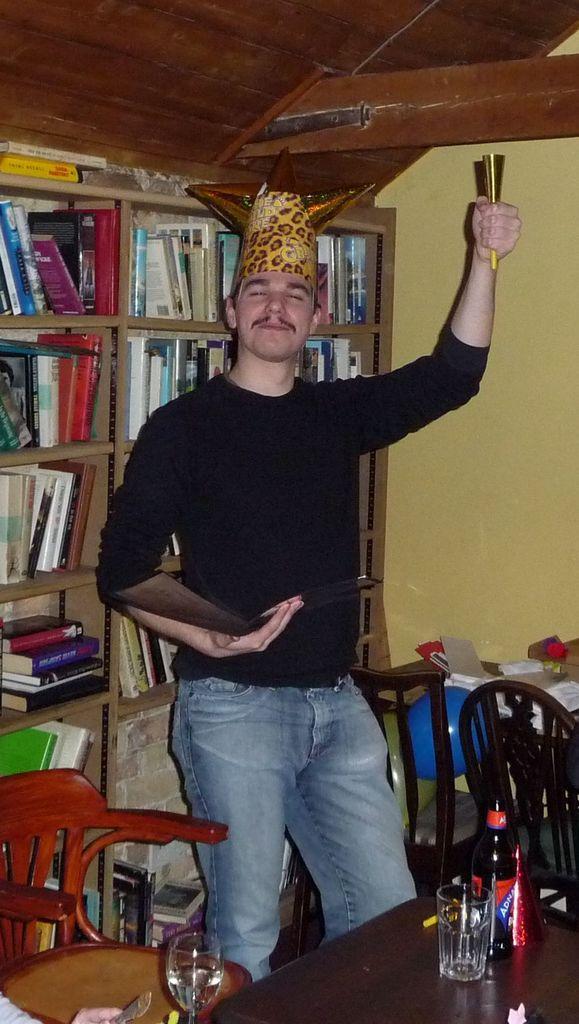Describe this image in one or two sentences. In this image there is a person wearing black color T-shirt standing and holding something in his left hand and in front of him there is a bottle,glass and at the background of the image there are books in the shelf. 